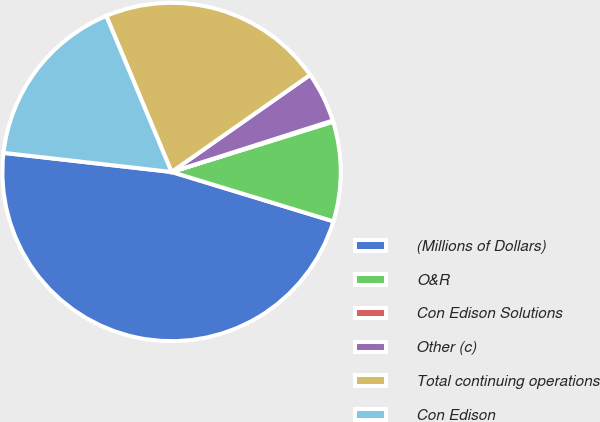Convert chart to OTSL. <chart><loc_0><loc_0><loc_500><loc_500><pie_chart><fcel>(Millions of Dollars)<fcel>O&R<fcel>Con Edison Solutions<fcel>Other (c)<fcel>Total continuing operations<fcel>Con Edison<nl><fcel>47.09%<fcel>9.51%<fcel>0.12%<fcel>4.81%<fcel>21.58%<fcel>16.89%<nl></chart> 